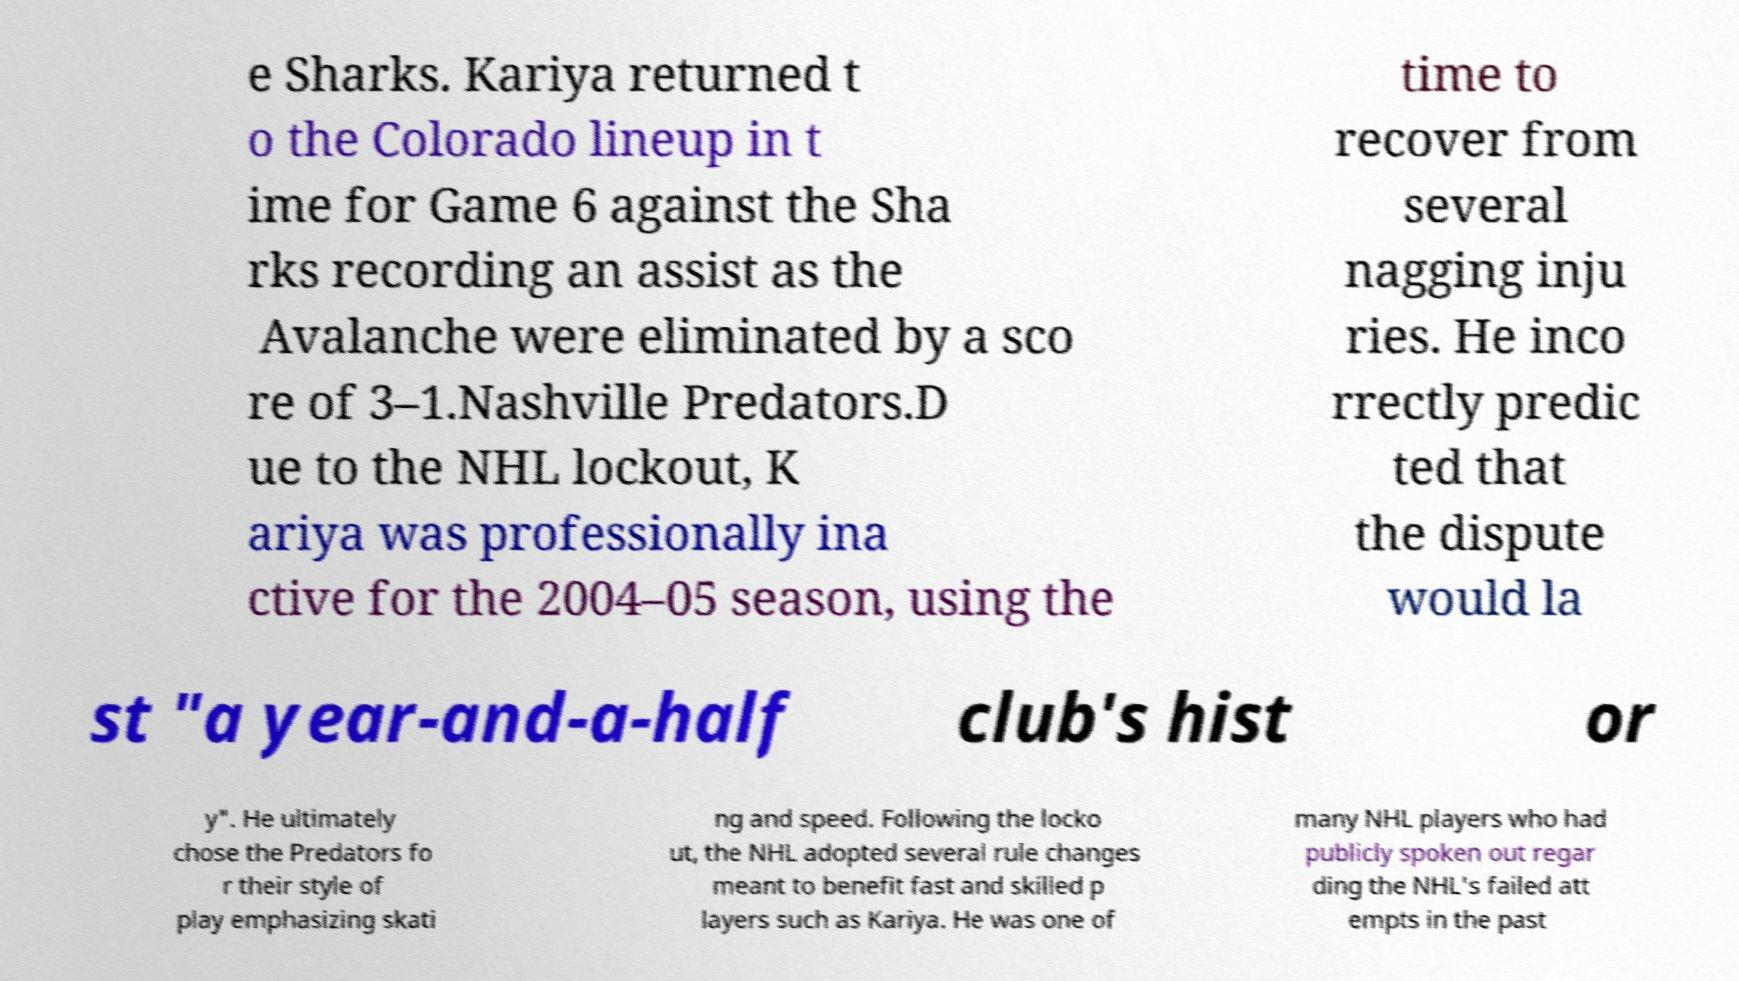Can you accurately transcribe the text from the provided image for me? e Sharks. Kariya returned t o the Colorado lineup in t ime for Game 6 against the Sha rks recording an assist as the Avalanche were eliminated by a sco re of 3–1.Nashville Predators.D ue to the NHL lockout, K ariya was professionally ina ctive for the 2004–05 season, using the time to recover from several nagging inju ries. He inco rrectly predic ted that the dispute would la st "a year-and-a-half club's hist or y". He ultimately chose the Predators fo r their style of play emphasizing skati ng and speed. Following the locko ut, the NHL adopted several rule changes meant to benefit fast and skilled p layers such as Kariya. He was one of many NHL players who had publicly spoken out regar ding the NHL's failed att empts in the past 